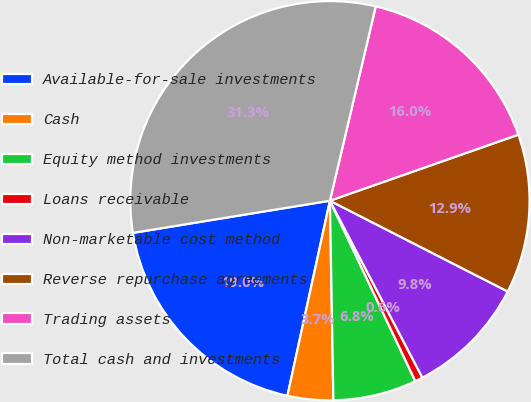Convert chart. <chart><loc_0><loc_0><loc_500><loc_500><pie_chart><fcel>Available-for-sale investments<fcel>Cash<fcel>Equity method investments<fcel>Loans receivable<fcel>Non-marketable cost method<fcel>Reverse repurchase agreements<fcel>Trading assets<fcel>Total cash and investments<nl><fcel>19.01%<fcel>3.69%<fcel>6.76%<fcel>0.63%<fcel>9.82%<fcel>12.88%<fcel>15.95%<fcel>31.26%<nl></chart> 